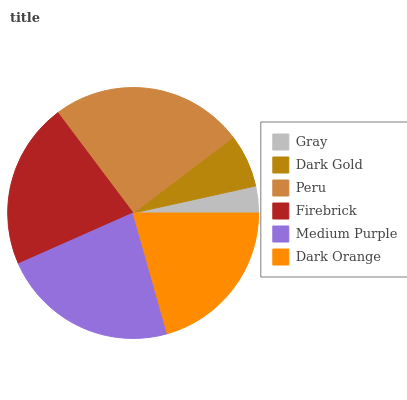Is Gray the minimum?
Answer yes or no. Yes. Is Peru the maximum?
Answer yes or no. Yes. Is Dark Gold the minimum?
Answer yes or no. No. Is Dark Gold the maximum?
Answer yes or no. No. Is Dark Gold greater than Gray?
Answer yes or no. Yes. Is Gray less than Dark Gold?
Answer yes or no. Yes. Is Gray greater than Dark Gold?
Answer yes or no. No. Is Dark Gold less than Gray?
Answer yes or no. No. Is Firebrick the high median?
Answer yes or no. Yes. Is Dark Orange the low median?
Answer yes or no. Yes. Is Medium Purple the high median?
Answer yes or no. No. Is Gray the low median?
Answer yes or no. No. 